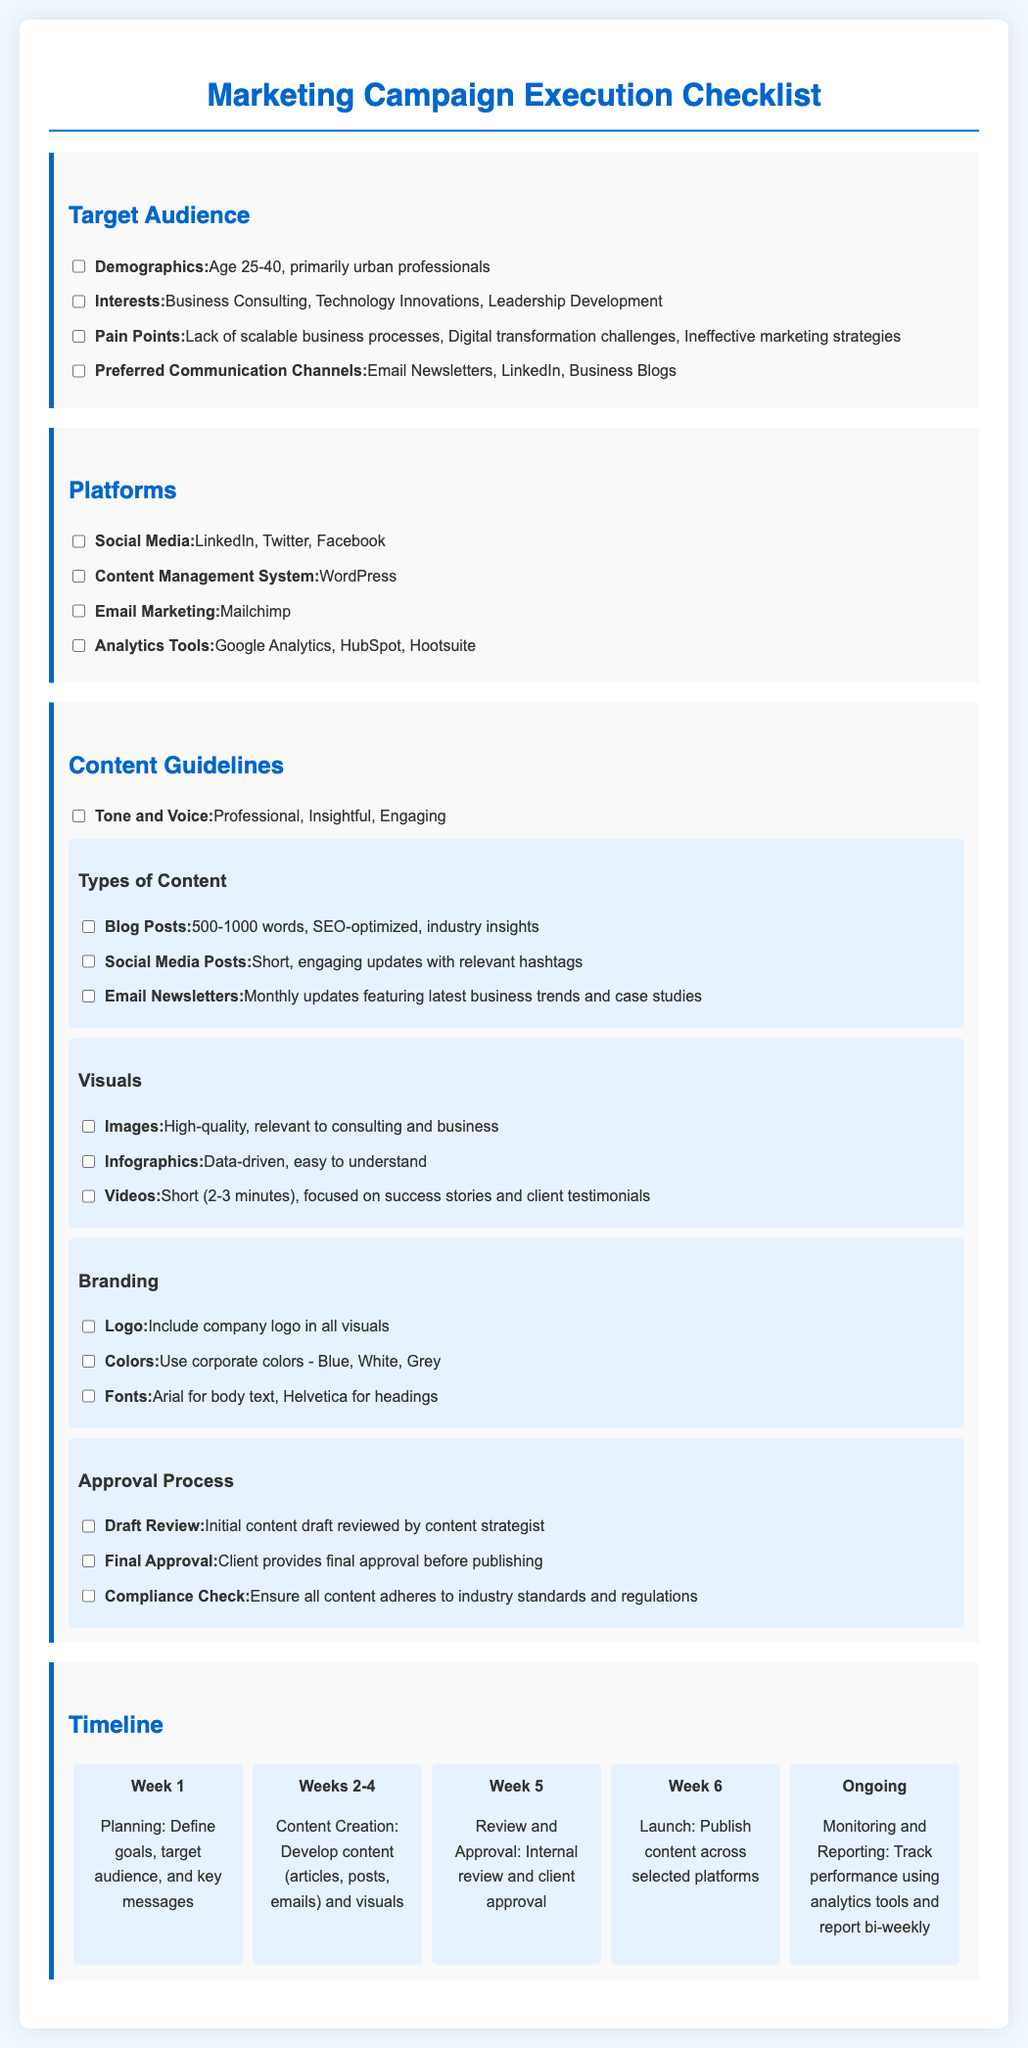What is the target age range for the audience? The target age range is specified under the Target Audience section of the document, stating age 25-40.
Answer: Age 25-40 Which platform is used for Email Marketing? The platform for Email Marketing is mentioned under the Platforms section, which is Mailchimp.
Answer: Mailchimp How many types of visuals are listed in the Content Guidelines? The types of visuals are listed under the Visuals subsection, which mentions three types: Images, Infographics, and Videos.
Answer: Three What is the primary tone for the content? The tone is specified in the Content Guidelines section, indicating it should be Professional, Insightful, and Engaging.
Answer: Professional, Insightful, Engaging What is the duration for monitoring and reporting after the campaign launch? The monitoring and reporting duration is mentioned in the Timeline section as ongoing, which indicates it continues indefinitely after the launch.
Answer: Ongoing What is the first task in the marketing campaign timeline? The first task is listed in the Timeline section as Planning, which includes defining goals, target audience, and key messages.
Answer: Planning Who provides the final approval for the content? The final approval responsibility is noted in the Approval Process subsection, stating that the client provides final approval before publishing.
Answer: Client How many weeks are allocated for content creation? The document allocates three weeks (Weeks 2-4) for content creation according to the Timeline section.
Answer: Three weeks What is the purpose of the compliance check? The purpose of the compliance check is stated under the Approval Process subsection, which ensures all content adheres to industry standards and regulations.
Answer: Adheres to industry standards and regulations 